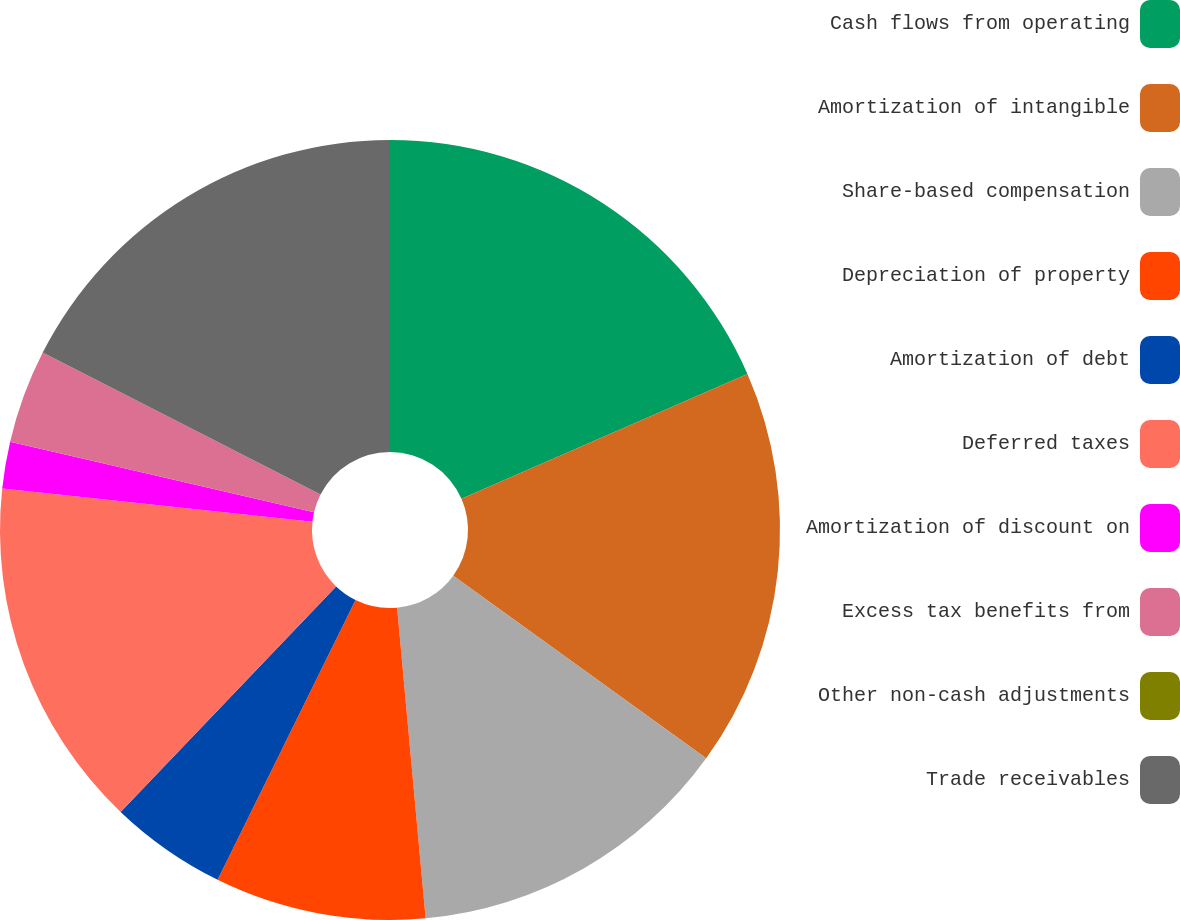<chart> <loc_0><loc_0><loc_500><loc_500><pie_chart><fcel>Cash flows from operating<fcel>Amortization of intangible<fcel>Share-based compensation<fcel>Depreciation of property<fcel>Amortization of debt<fcel>Deferred taxes<fcel>Amortization of discount on<fcel>Excess tax benefits from<fcel>Other non-cash adjustments<fcel>Trade receivables<nl><fcel>18.45%<fcel>16.5%<fcel>13.59%<fcel>8.74%<fcel>4.85%<fcel>14.56%<fcel>1.94%<fcel>3.88%<fcel>0.0%<fcel>17.48%<nl></chart> 